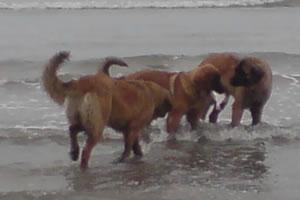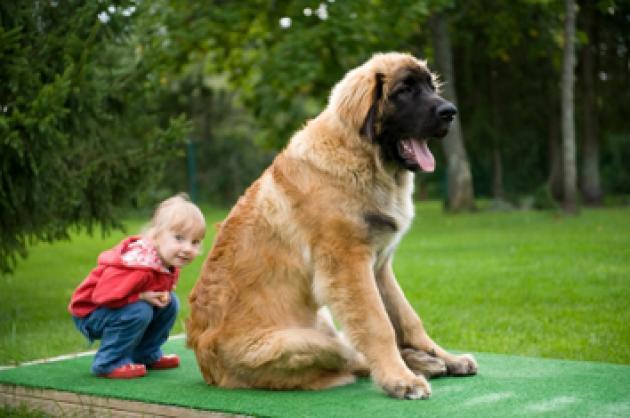The first image is the image on the left, the second image is the image on the right. For the images displayed, is the sentence "In one image, three dogs are shown together on a ground containing water in one of its states of matter." factually correct? Answer yes or no. Yes. The first image is the image on the left, the second image is the image on the right. Examine the images to the left and right. Is the description "There are two dogs outside in the grass in one of the images." accurate? Answer yes or no. No. 